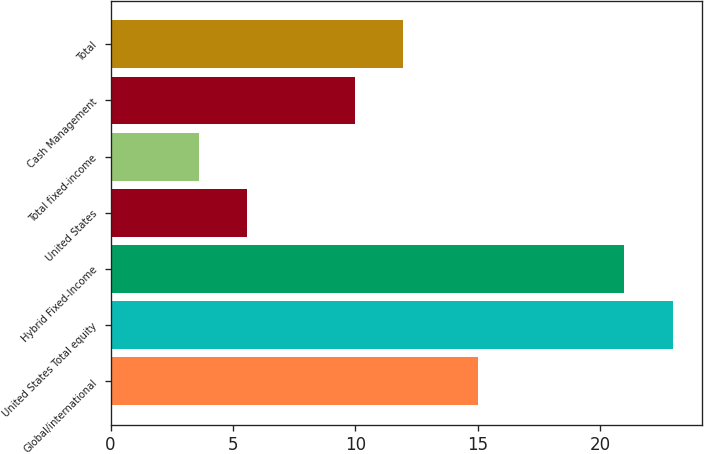Convert chart. <chart><loc_0><loc_0><loc_500><loc_500><bar_chart><fcel>Global/international<fcel>United States Total equity<fcel>Hybrid Fixed-Income<fcel>United States<fcel>Total fixed-income<fcel>Cash Management<fcel>Total<nl><fcel>15<fcel>23<fcel>21<fcel>5.57<fcel>3.63<fcel>10<fcel>11.94<nl></chart> 